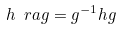Convert formula to latex. <formula><loc_0><loc_0><loc_500><loc_500>h \ r a g = g ^ { - 1 } h g</formula> 